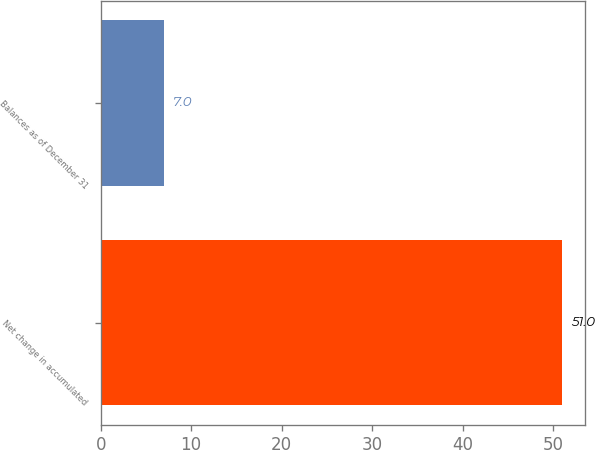Convert chart. <chart><loc_0><loc_0><loc_500><loc_500><bar_chart><fcel>Net change in accumulated<fcel>Balances as of December 31<nl><fcel>51<fcel>7<nl></chart> 